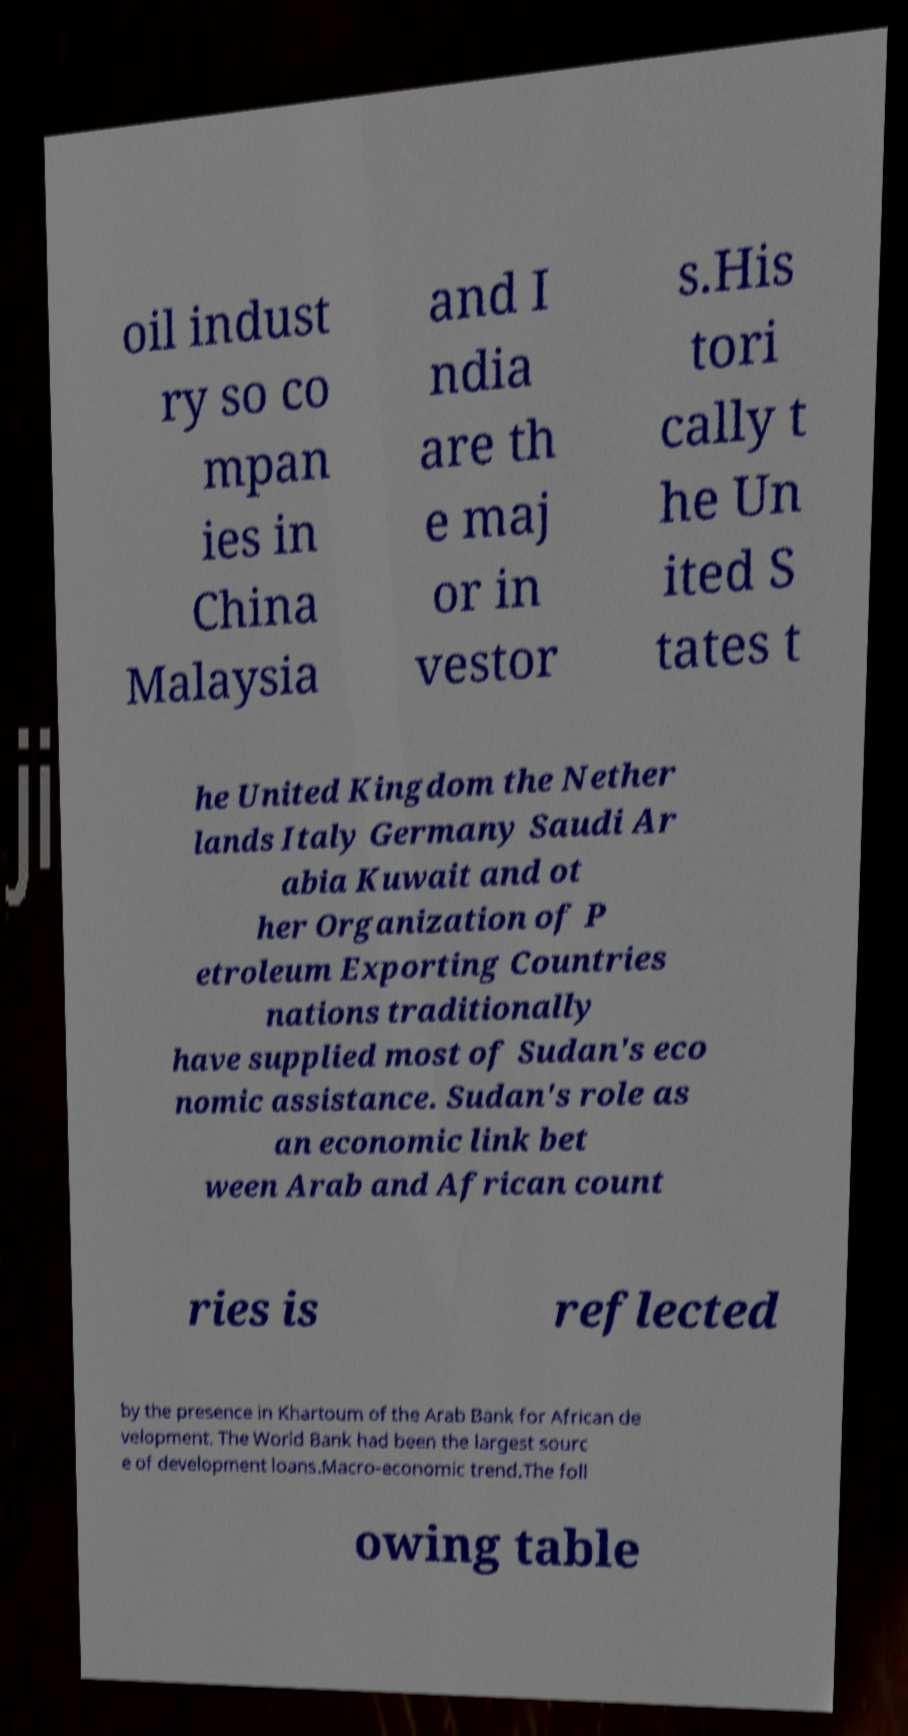Could you extract and type out the text from this image? oil indust ry so co mpan ies in China Malaysia and I ndia are th e maj or in vestor s.His tori cally t he Un ited S tates t he United Kingdom the Nether lands Italy Germany Saudi Ar abia Kuwait and ot her Organization of P etroleum Exporting Countries nations traditionally have supplied most of Sudan's eco nomic assistance. Sudan's role as an economic link bet ween Arab and African count ries is reflected by the presence in Khartoum of the Arab Bank for African de velopment. The World Bank had been the largest sourc e of development loans.Macro-economic trend.The foll owing table 